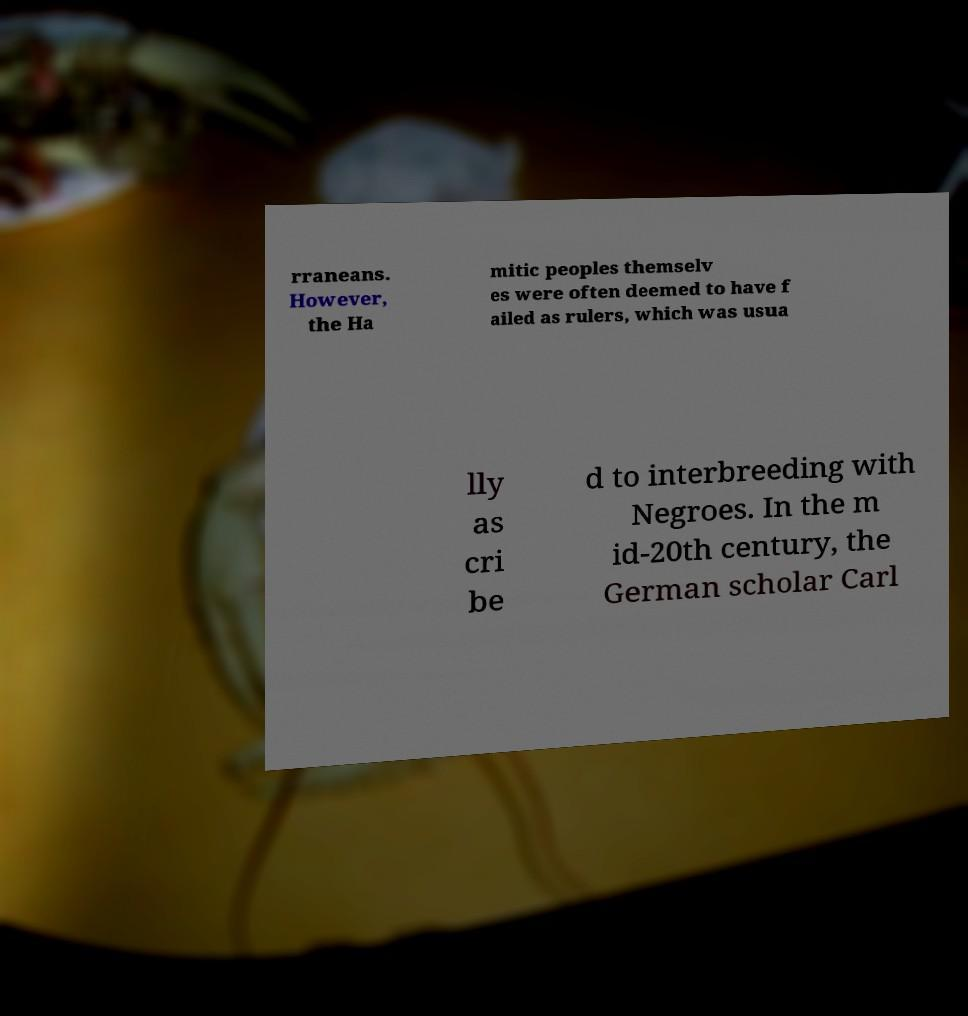Can you accurately transcribe the text from the provided image for me? rraneans. However, the Ha mitic peoples themselv es were often deemed to have f ailed as rulers, which was usua lly as cri be d to interbreeding with Negroes. In the m id-20th century, the German scholar Carl 